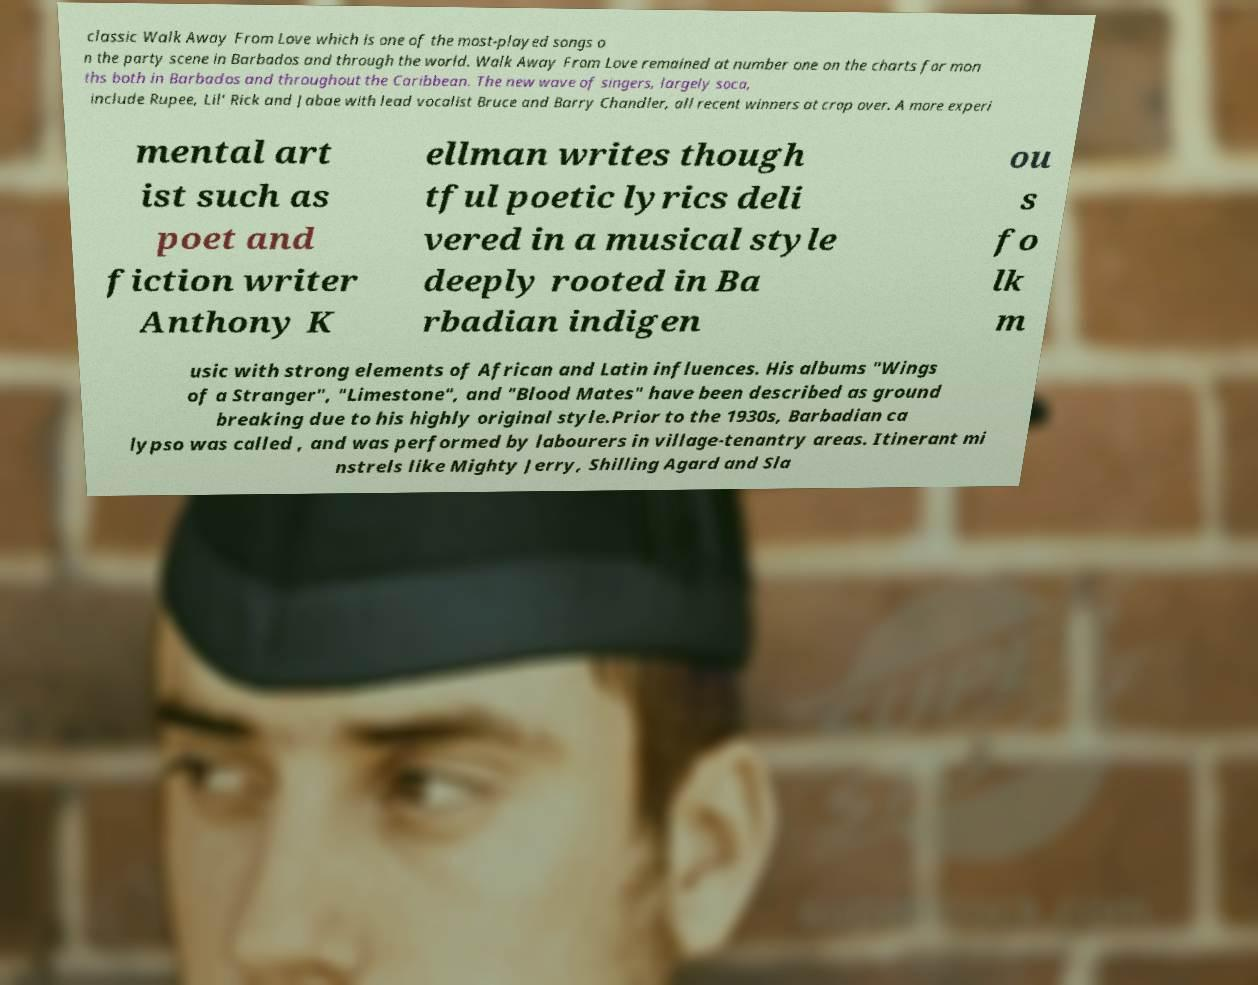Could you assist in decoding the text presented in this image and type it out clearly? classic Walk Away From Love which is one of the most-played songs o n the party scene in Barbados and through the world. Walk Away From Love remained at number one on the charts for mon ths both in Barbados and throughout the Caribbean. The new wave of singers, largely soca, include Rupee, Lil' Rick and Jabae with lead vocalist Bruce and Barry Chandler, all recent winners at crop over. A more experi mental art ist such as poet and fiction writer Anthony K ellman writes though tful poetic lyrics deli vered in a musical style deeply rooted in Ba rbadian indigen ou s fo lk m usic with strong elements of African and Latin influences. His albums "Wings of a Stranger", "Limestone", and "Blood Mates" have been described as ground breaking due to his highly original style.Prior to the 1930s, Barbadian ca lypso was called , and was performed by labourers in village-tenantry areas. Itinerant mi nstrels like Mighty Jerry, Shilling Agard and Sla 